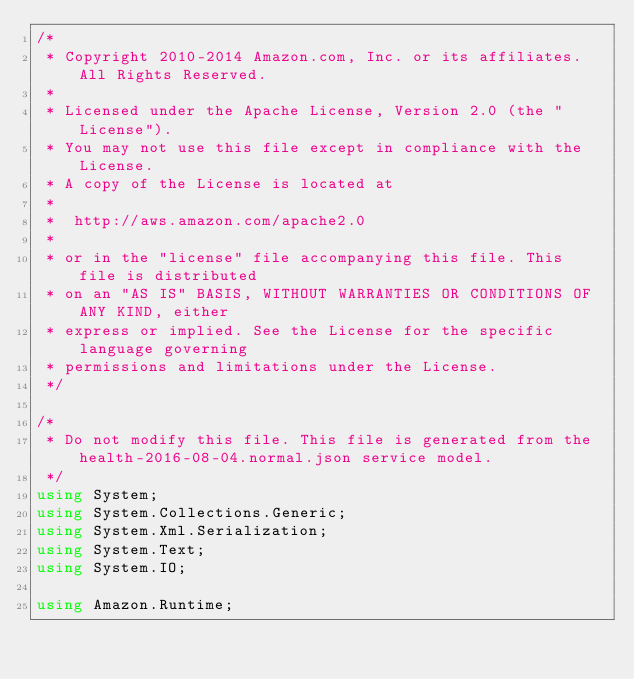Convert code to text. <code><loc_0><loc_0><loc_500><loc_500><_C#_>/*
 * Copyright 2010-2014 Amazon.com, Inc. or its affiliates. All Rights Reserved.
 * 
 * Licensed under the Apache License, Version 2.0 (the "License").
 * You may not use this file except in compliance with the License.
 * A copy of the License is located at
 * 
 *  http://aws.amazon.com/apache2.0
 * 
 * or in the "license" file accompanying this file. This file is distributed
 * on an "AS IS" BASIS, WITHOUT WARRANTIES OR CONDITIONS OF ANY KIND, either
 * express or implied. See the License for the specific language governing
 * permissions and limitations under the License.
 */

/*
 * Do not modify this file. This file is generated from the health-2016-08-04.normal.json service model.
 */
using System;
using System.Collections.Generic;
using System.Xml.Serialization;
using System.Text;
using System.IO;

using Amazon.Runtime;</code> 